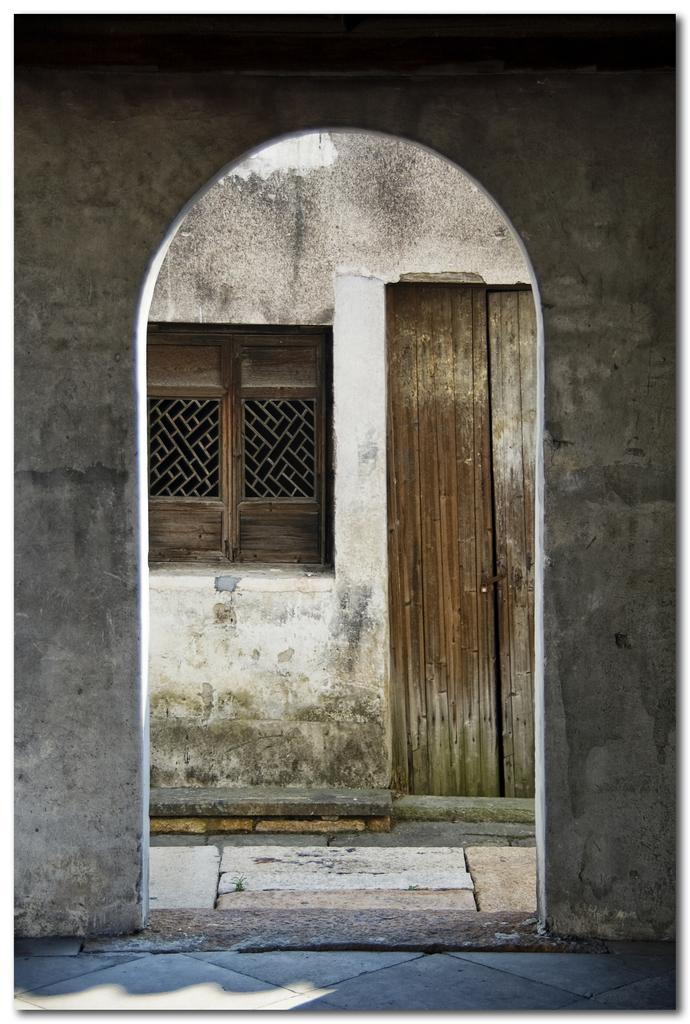What type of structure can be seen in the image? There is an arch in the image. What other type of structure is present in the image? There is a building in the image. What features can be observed on the building? The building has a door and a window. What type of lamp can be seen on the building's chin in the image? There is no lamp or chin present on the building in the image. 